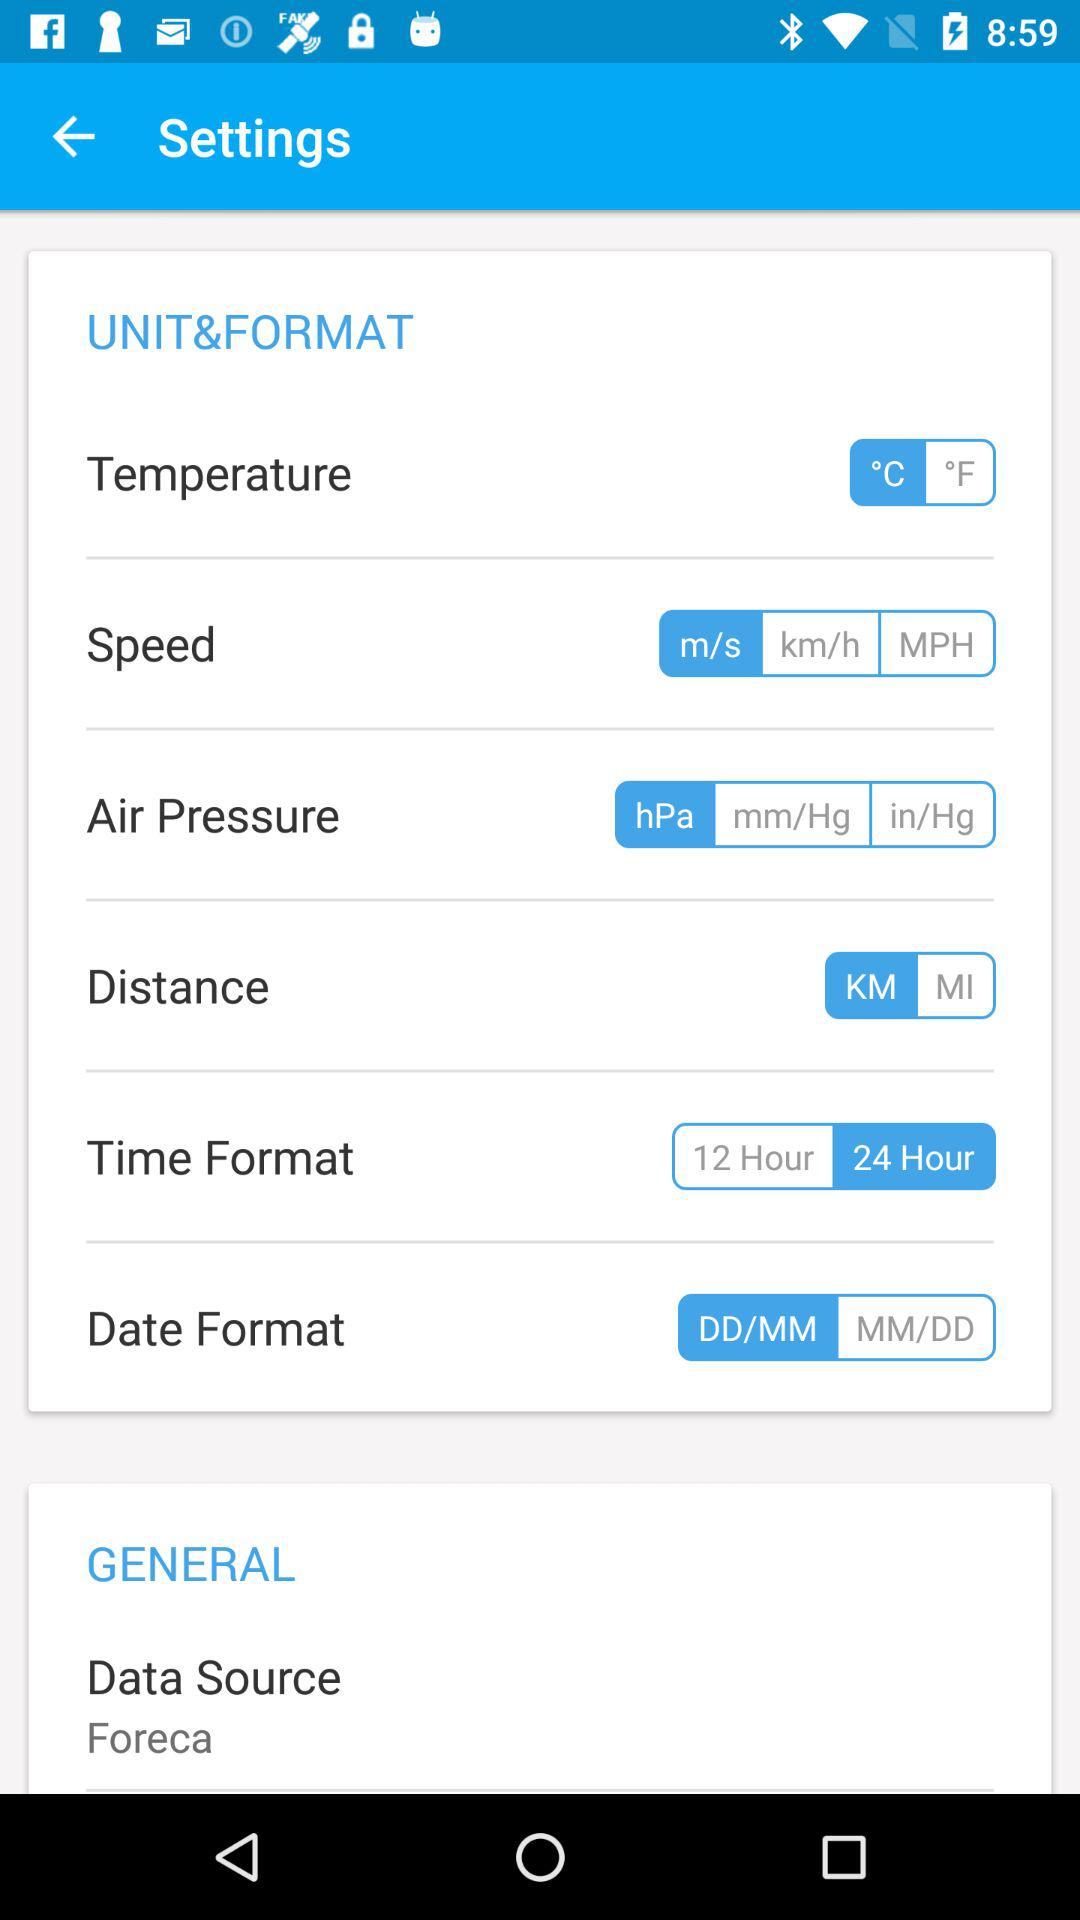What is the selected air pressure unit? The selected air pressure unit is "hPa". 